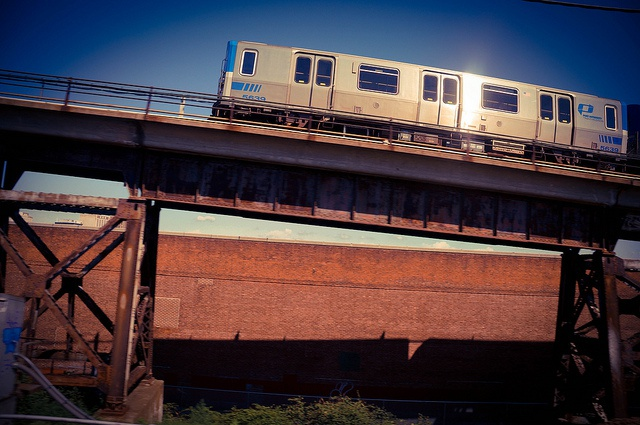Describe the objects in this image and their specific colors. I can see a train in navy, black, tan, and gray tones in this image. 